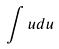Convert formula to latex. <formula><loc_0><loc_0><loc_500><loc_500>\int u d u</formula> 